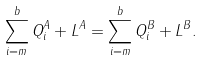Convert formula to latex. <formula><loc_0><loc_0><loc_500><loc_500>\sum _ { i = m } ^ { b } Q _ { i } ^ { A } + L ^ { A } = \sum _ { i = m } ^ { b } Q _ { i } ^ { B } + L ^ { B } .</formula> 